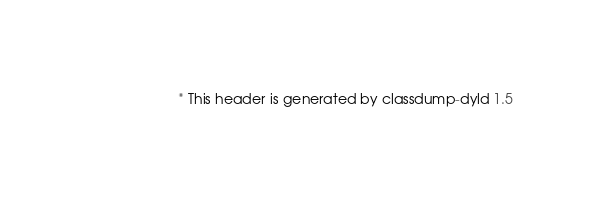<code> <loc_0><loc_0><loc_500><loc_500><_C_>                       * This header is generated by classdump-dyld 1.5</code> 